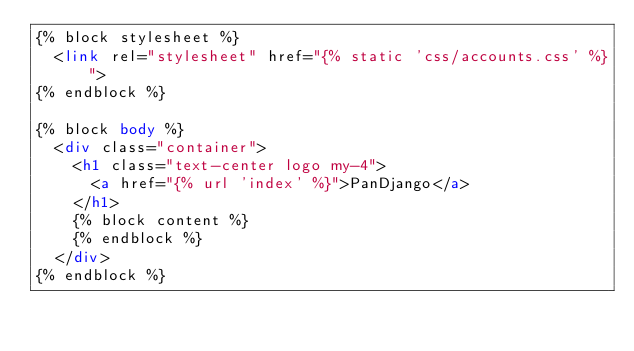<code> <loc_0><loc_0><loc_500><loc_500><_HTML_>{% block stylesheet %}
  <link rel="stylesheet" href="{% static 'css/accounts.css' %}">
{% endblock %}

{% block body %}
  <div class="container">
    <h1 class="text-center logo my-4">
      <a href="{% url 'index' %}">PanDjango</a>
    </h1>
    {% block content %}
    {% endblock %}
  </div>
{% endblock %}</code> 